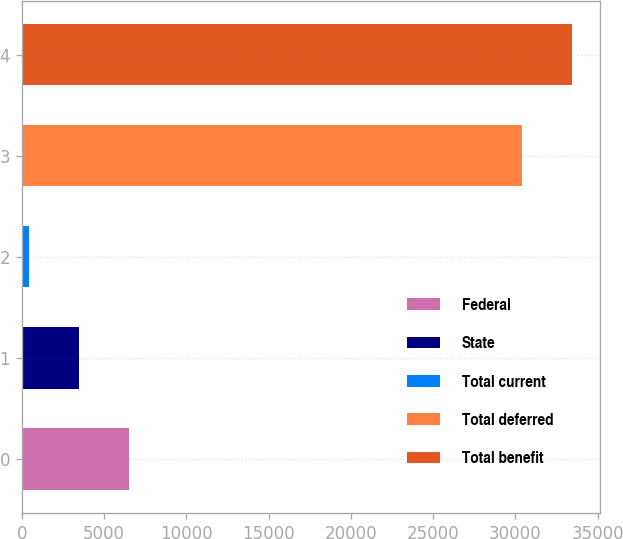Convert chart. <chart><loc_0><loc_0><loc_500><loc_500><bar_chart><fcel>Federal<fcel>State<fcel>Total current<fcel>Total deferred<fcel>Total benefit<nl><fcel>6497.6<fcel>3455.3<fcel>413<fcel>30423<fcel>33465.3<nl></chart> 